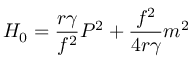Convert formula to latex. <formula><loc_0><loc_0><loc_500><loc_500>H _ { 0 } = \frac { r { \gamma } } { f ^ { 2 } } P ^ { 2 } + \frac { f ^ { 2 } } { 4 r { \gamma } } m ^ { 2 }</formula> 